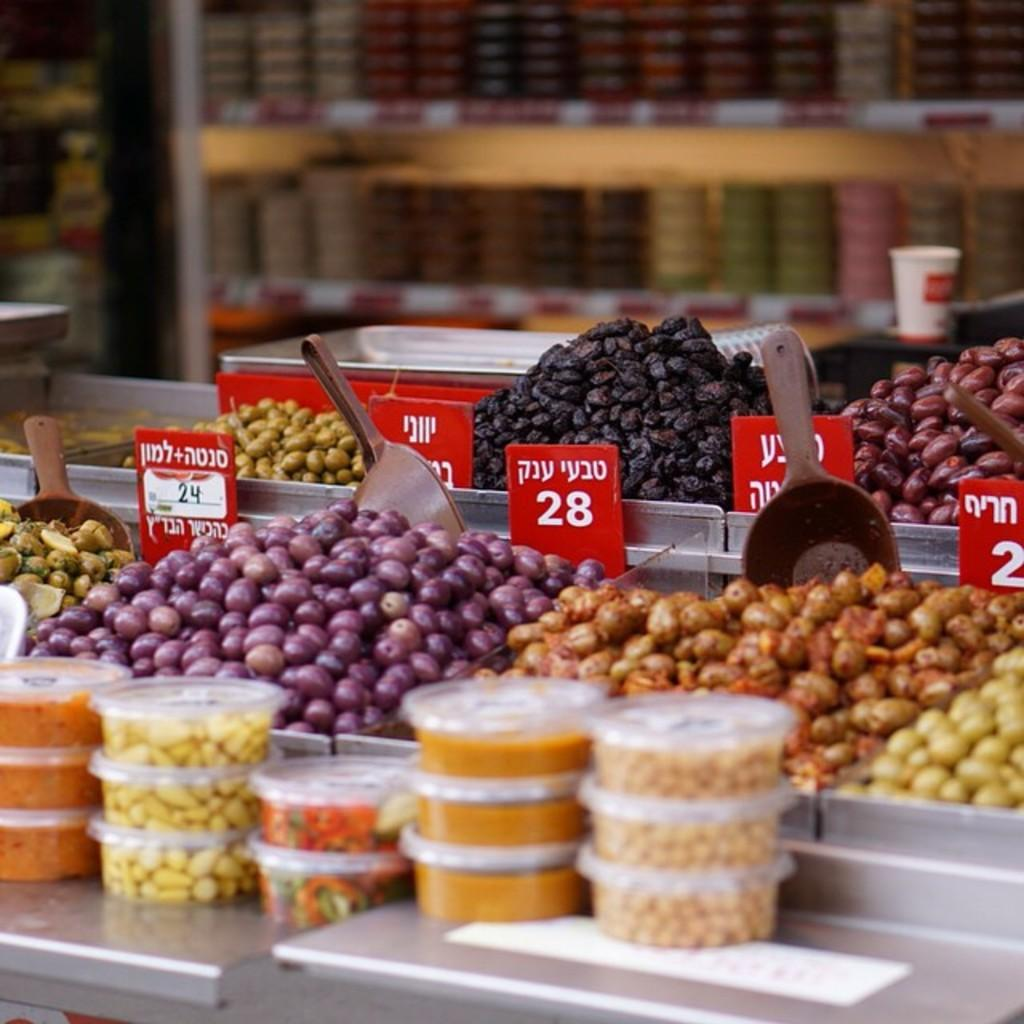What type of food can be seen in the image? There are fruits in the image. How are some of the fruits arranged in the image? Some fruits are packed in boxes. What utensils are visible in the image? There are spoons visible in the image. Can you describe the background of the image? The background of the image is blurred. What type of band is playing in the background of the image? There is no band present in the image; the background is blurred. 